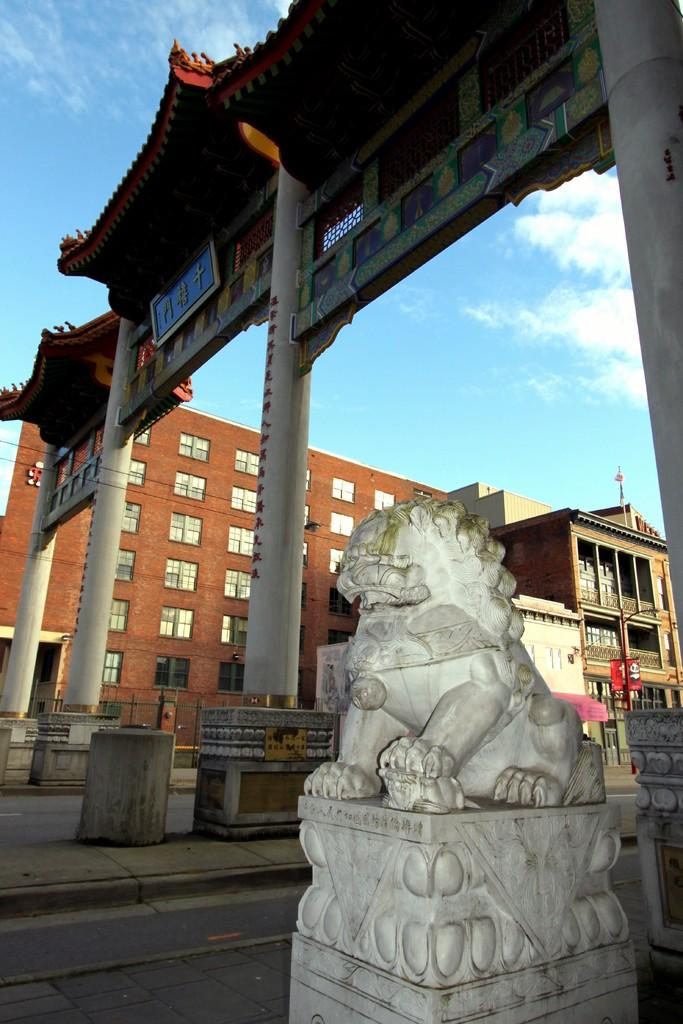What is the main subject of the image? There is a white color statue in the image. What architectural features are present in the image? There are pillars in the image. Are there any other objects or structures visible in the image? Yes, there are other objects in the image. What can be seen in the background of the image? There are buildings and the sky visible in the background of the image. What type of fiction is the squirrel reading in the image? There is no squirrel or any reading material present in the image. What is the statue made of, and what color is it? The statue is made of an unknown material, but it appears to be white in color. 